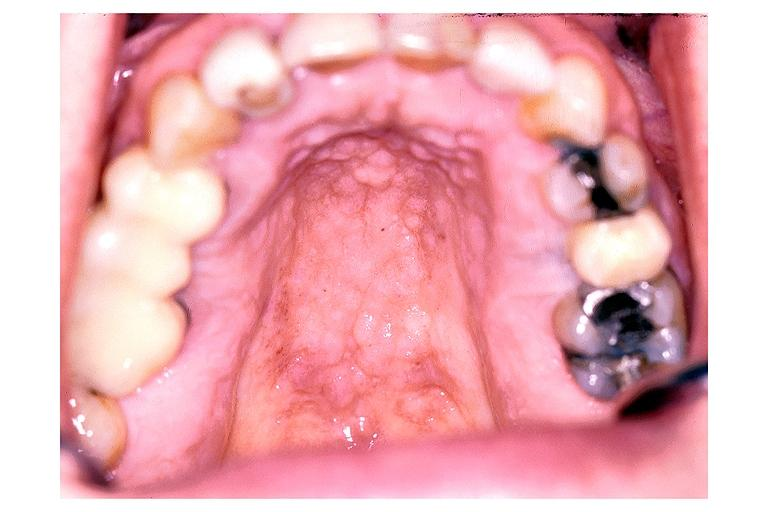what is present?
Answer the question using a single word or phrase. Oral 